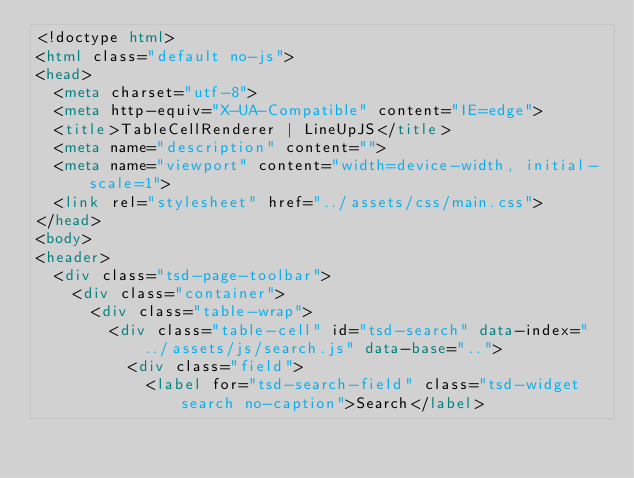Convert code to text. <code><loc_0><loc_0><loc_500><loc_500><_HTML_><!doctype html>
<html class="default no-js">
<head>
	<meta charset="utf-8">
	<meta http-equiv="X-UA-Compatible" content="IE=edge">
	<title>TableCellRenderer | LineUpJS</title>
	<meta name="description" content="">
	<meta name="viewport" content="width=device-width, initial-scale=1">
	<link rel="stylesheet" href="../assets/css/main.css">
</head>
<body>
<header>
	<div class="tsd-page-toolbar">
		<div class="container">
			<div class="table-wrap">
				<div class="table-cell" id="tsd-search" data-index="../assets/js/search.js" data-base="..">
					<div class="field">
						<label for="tsd-search-field" class="tsd-widget search no-caption">Search</label></code> 